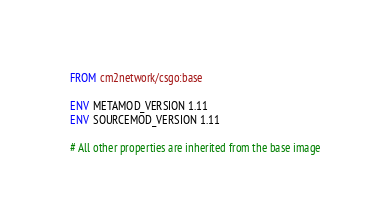<code> <loc_0><loc_0><loc_500><loc_500><_Dockerfile_>FROM cm2network/csgo:base

ENV METAMOD_VERSION 1.11
ENV SOURCEMOD_VERSION 1.11

# All other properties are inherited from the base image
</code> 